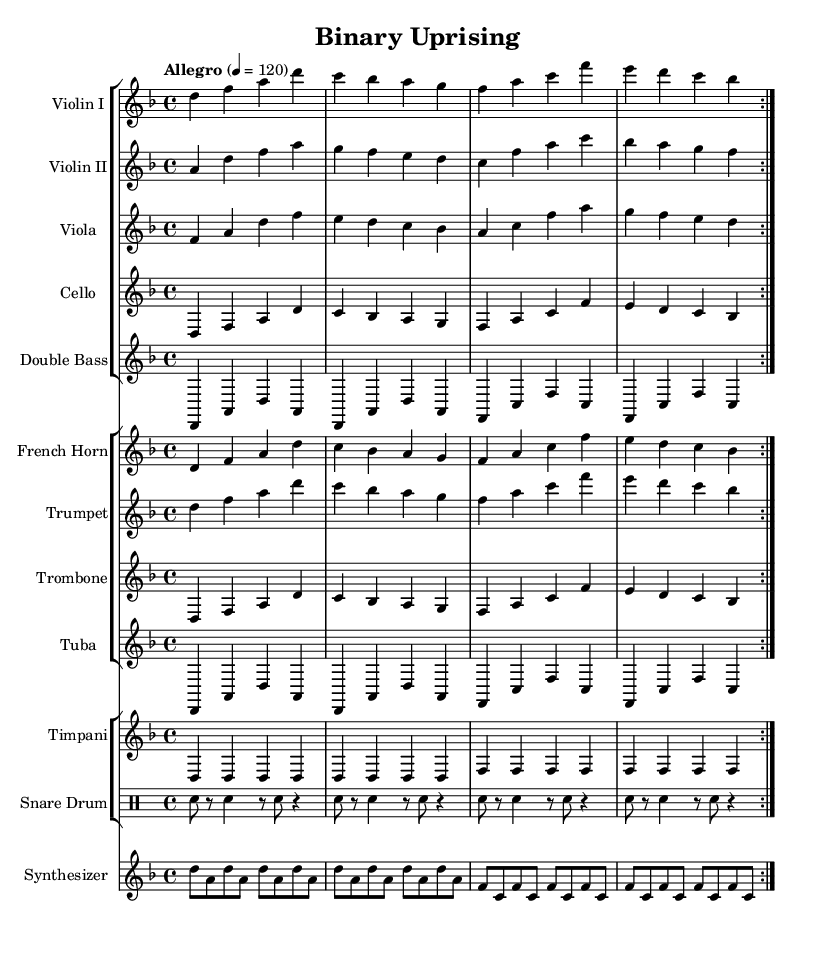What is the key signature of this music? The key signature is D minor, indicated by one flat (B flat) at the beginning of the staff.
Answer: D minor What is the time signature of this music? The time signature is 4/4, which means there are four beats in each measure and the quarter note gets one beat, shown at the beginning of the score.
Answer: 4/4 What is the tempo marking for this piece? The tempo marking is "Allegro" with a metronome marking of 120 beats per minute, indicating a fast tempo.
Answer: Allegro How many measures are repeated in the first section? The first section consists of two measures that repeat four times (due to the repeat signs) before moving to the next section.
Answer: Two What is the instrument that plays a prominent role along with the strings? The synthesizer is specifically included in this score and plays a distinct role alongside the orchestral strings.
Answer: Synthesizer What is the dynamic indication for the timpani part? The timpani part does not contain any specific dynamic markings, suggesting a standard dynamic throughout the piece unless otherwise noted.
Answer: None How many different brass instruments are used in this score? There are four brass instruments used: French Horn, Trumpet, Trombone, and Tuba, as indicated in the grouped staff sections.
Answer: Four 